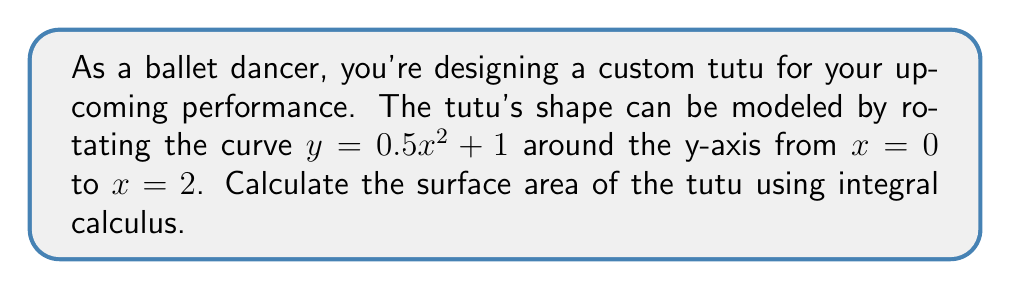Provide a solution to this math problem. To find the surface area of the tutu, we'll use the formula for the surface area of a solid of revolution:

$$S = 2\pi \int_a^b f(x) \sqrt{1 + [f'(x)]^2} dx$$

Where $f(x) = 0.5x^2 + 1$ and $f'(x) = x$

Steps:
1) Substitute the given function and its derivative into the formula:
   $$S = 2\pi \int_0^2 (0.5x^2 + 1) \sqrt{1 + x^2} dx$$

2) This integral is complex, so we'll use u-substitution:
   Let $u = 1 + x^2$, then $du = 2x dx$ or $\frac{1}{2}du = x dx$

3) Rewrite the integral:
   $$S = 2\pi \int_1^5 (\frac{u}{2}) \sqrt{u} \frac{1}{2} du$$
   $$S = \frac{\pi}{2} \int_1^5 u^{3/2} du$$

4) Integrate:
   $$S = \frac{\pi}{2} [\frac{2}{5}u^{5/2}]_1^5$$

5) Evaluate the bounds:
   $$S = \frac{\pi}{2} (\frac{2}{5}(5^{5/2}) - \frac{2}{5}(1^{5/2}))$$
   $$S = \frac{\pi}{2} (\frac{2}{5}(5\sqrt{5}) - \frac{2}{5})$$

6) Simplify:
   $$S = \pi (5\sqrt{5} - 1)$$

Therefore, the surface area of the tutu is $\pi (5\sqrt{5} - 1)$ square units.
Answer: $\pi (5\sqrt{5} - 1)$ square units 